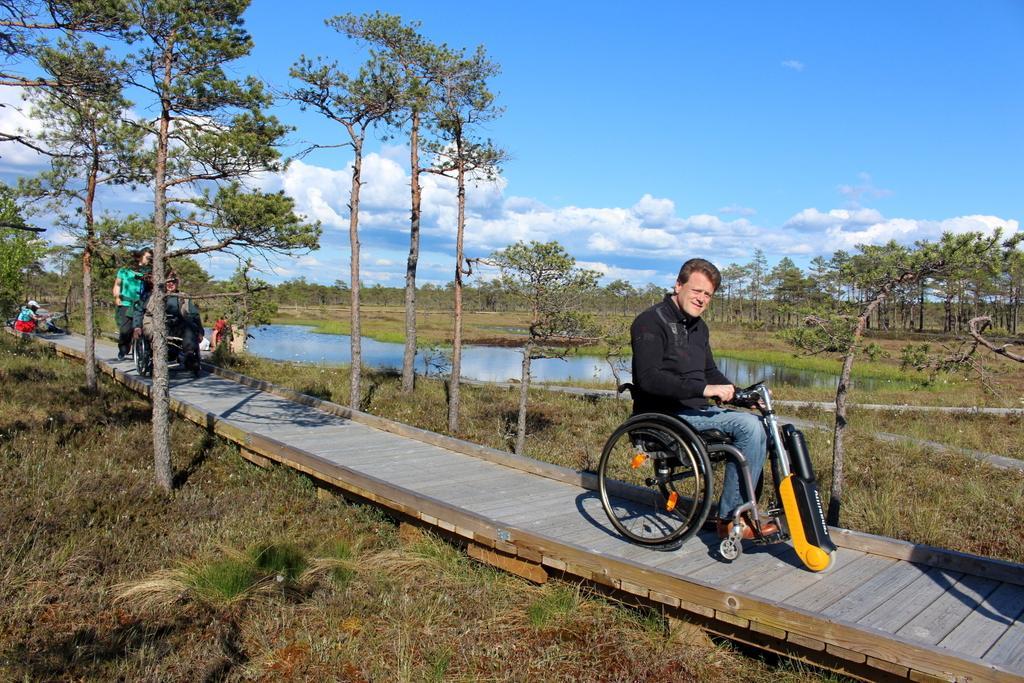How would you summarize this image in a sentence or two? In the picture I can see a man in the wheelchair. I can see another person in the wheelchair. In the background, I can see the pond, green grass and trees. There are clouds in the sky. 